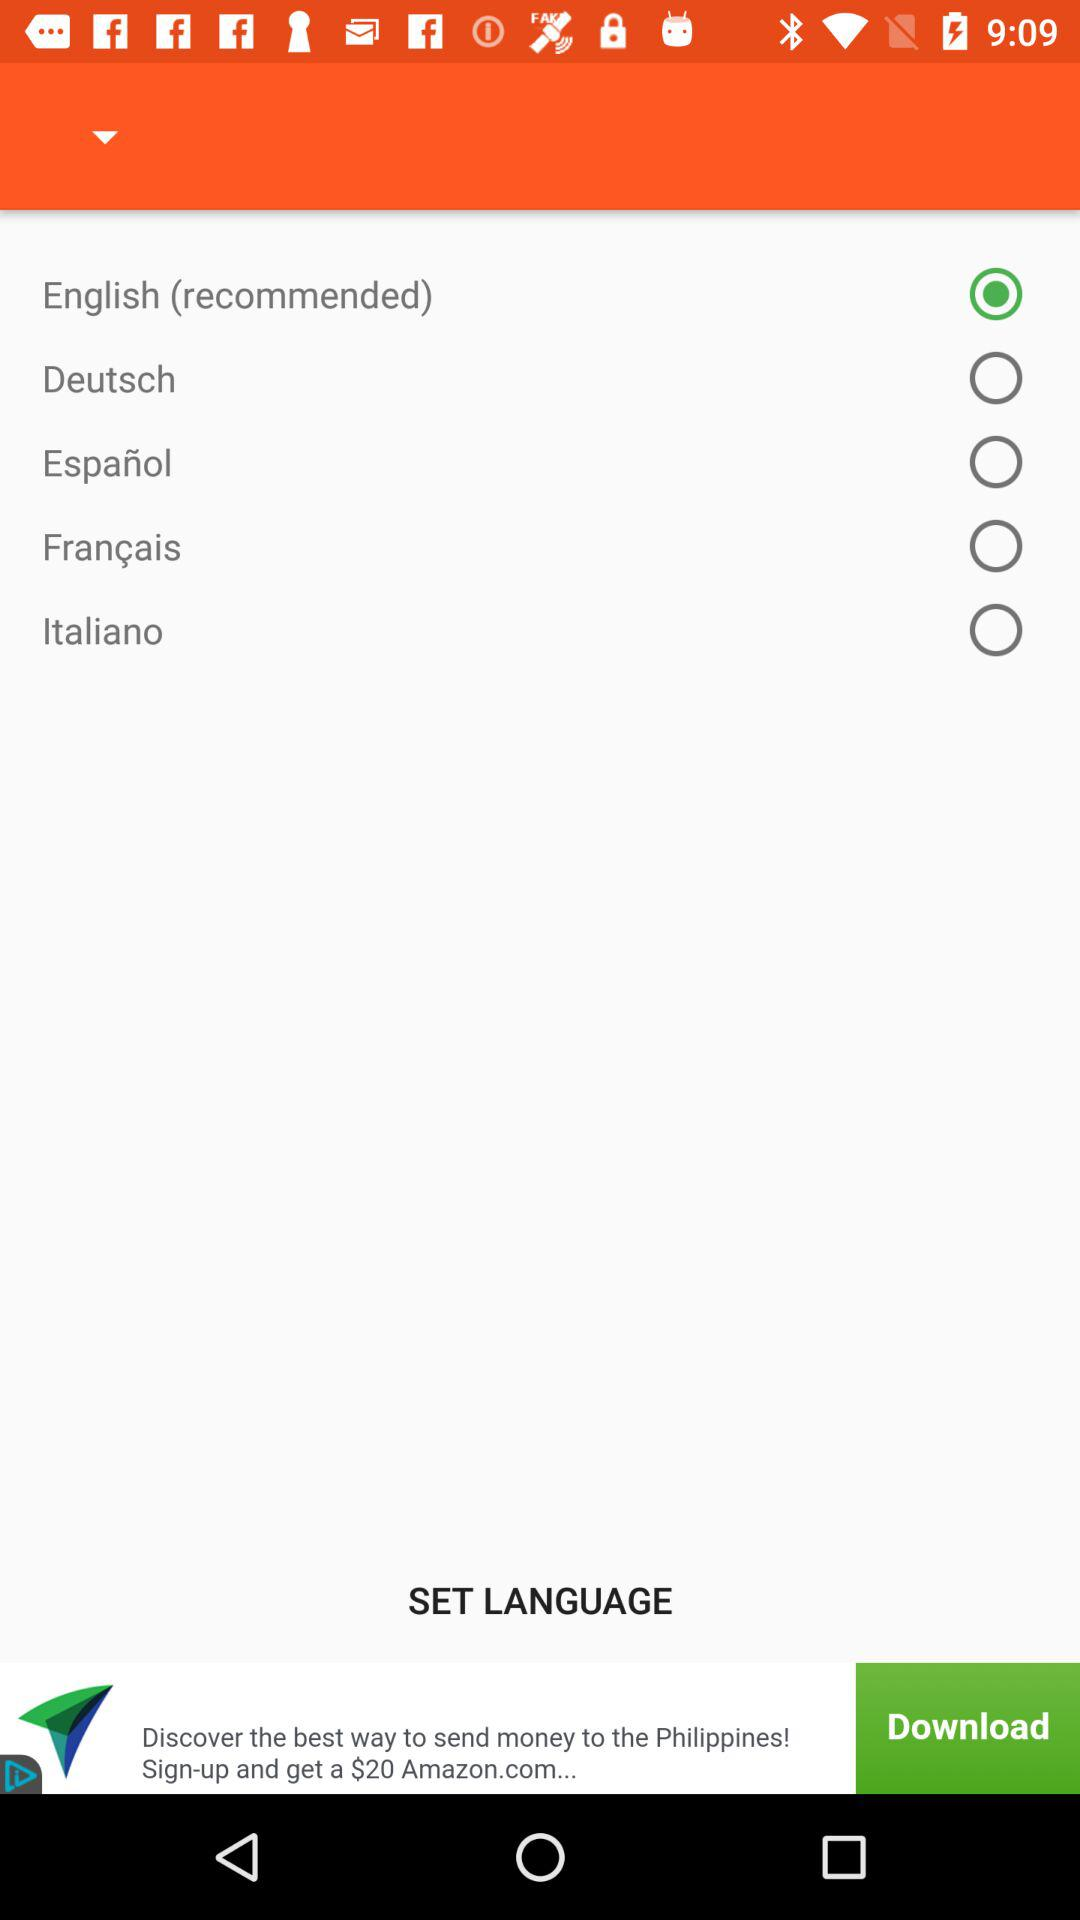Which language is selected? The selected language is English. 